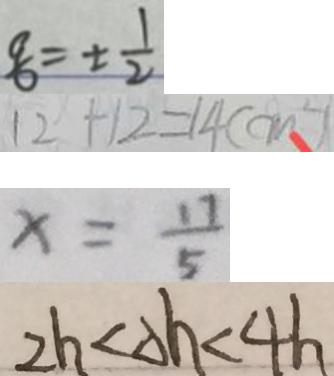Convert formula to latex. <formula><loc_0><loc_0><loc_500><loc_500>\frac { q } { b } = \pm \frac { 1 } { 2 } 
 1 2 + 1 2 = 1 4 ( c m ^ { 2 } ) 
 x = \frac { 1 7 } { 5 } 
 2 h < \Delta h < 4 h</formula> 